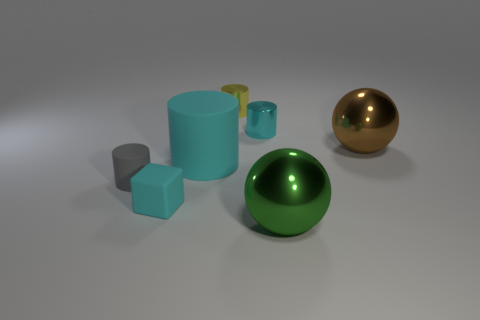There is a rubber object that is the same color as the tiny rubber cube; what is its size?
Offer a very short reply. Large. What is the shape of the metallic object that is the same color as the matte cube?
Your response must be concise. Cylinder. Is the large cylinder the same color as the block?
Offer a very short reply. Yes. Is the number of cyan rubber cylinders to the right of the green thing greater than the number of small cyan matte things?
Make the answer very short. No. What number of other objects are the same material as the gray cylinder?
Your answer should be very brief. 2. What number of big objects are shiny cylinders or cyan metallic cylinders?
Provide a short and direct response. 0. Is the material of the tiny cube the same as the tiny yellow object?
Make the answer very short. No. There is a ball that is in front of the cyan matte cube; how many tiny matte cylinders are on the right side of it?
Give a very brief answer. 0. Are there any large green things of the same shape as the large brown metallic thing?
Your response must be concise. Yes. There is a big metal thing in front of the cyan rubber block; is its shape the same as the small metal object to the right of the yellow shiny object?
Provide a short and direct response. No. 